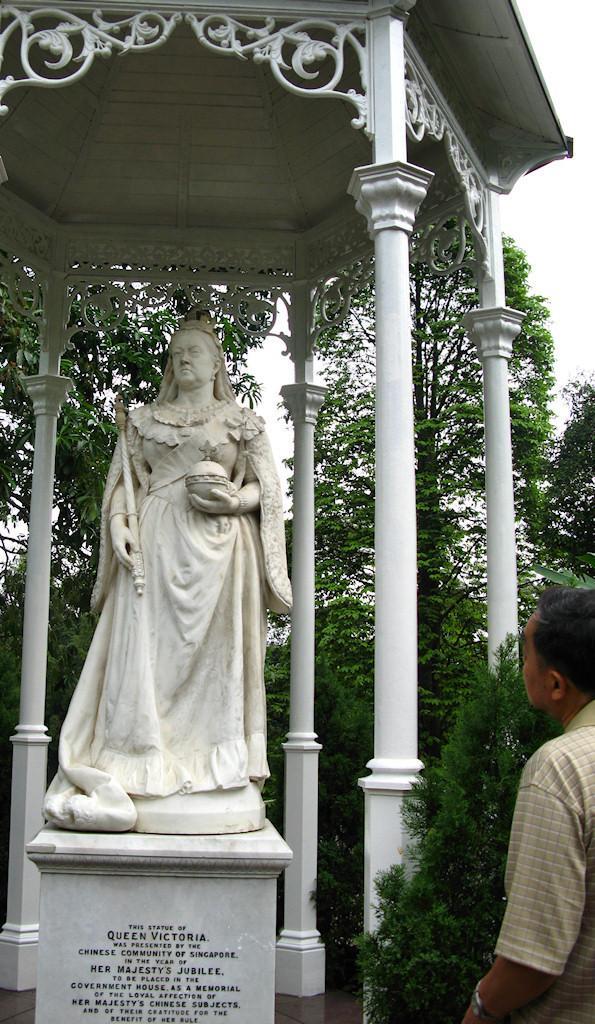Describe this image in one or two sentences. In this image, we can see a statue, we can see some pillars. There are some trees, on the right side, we can see a person standing. 